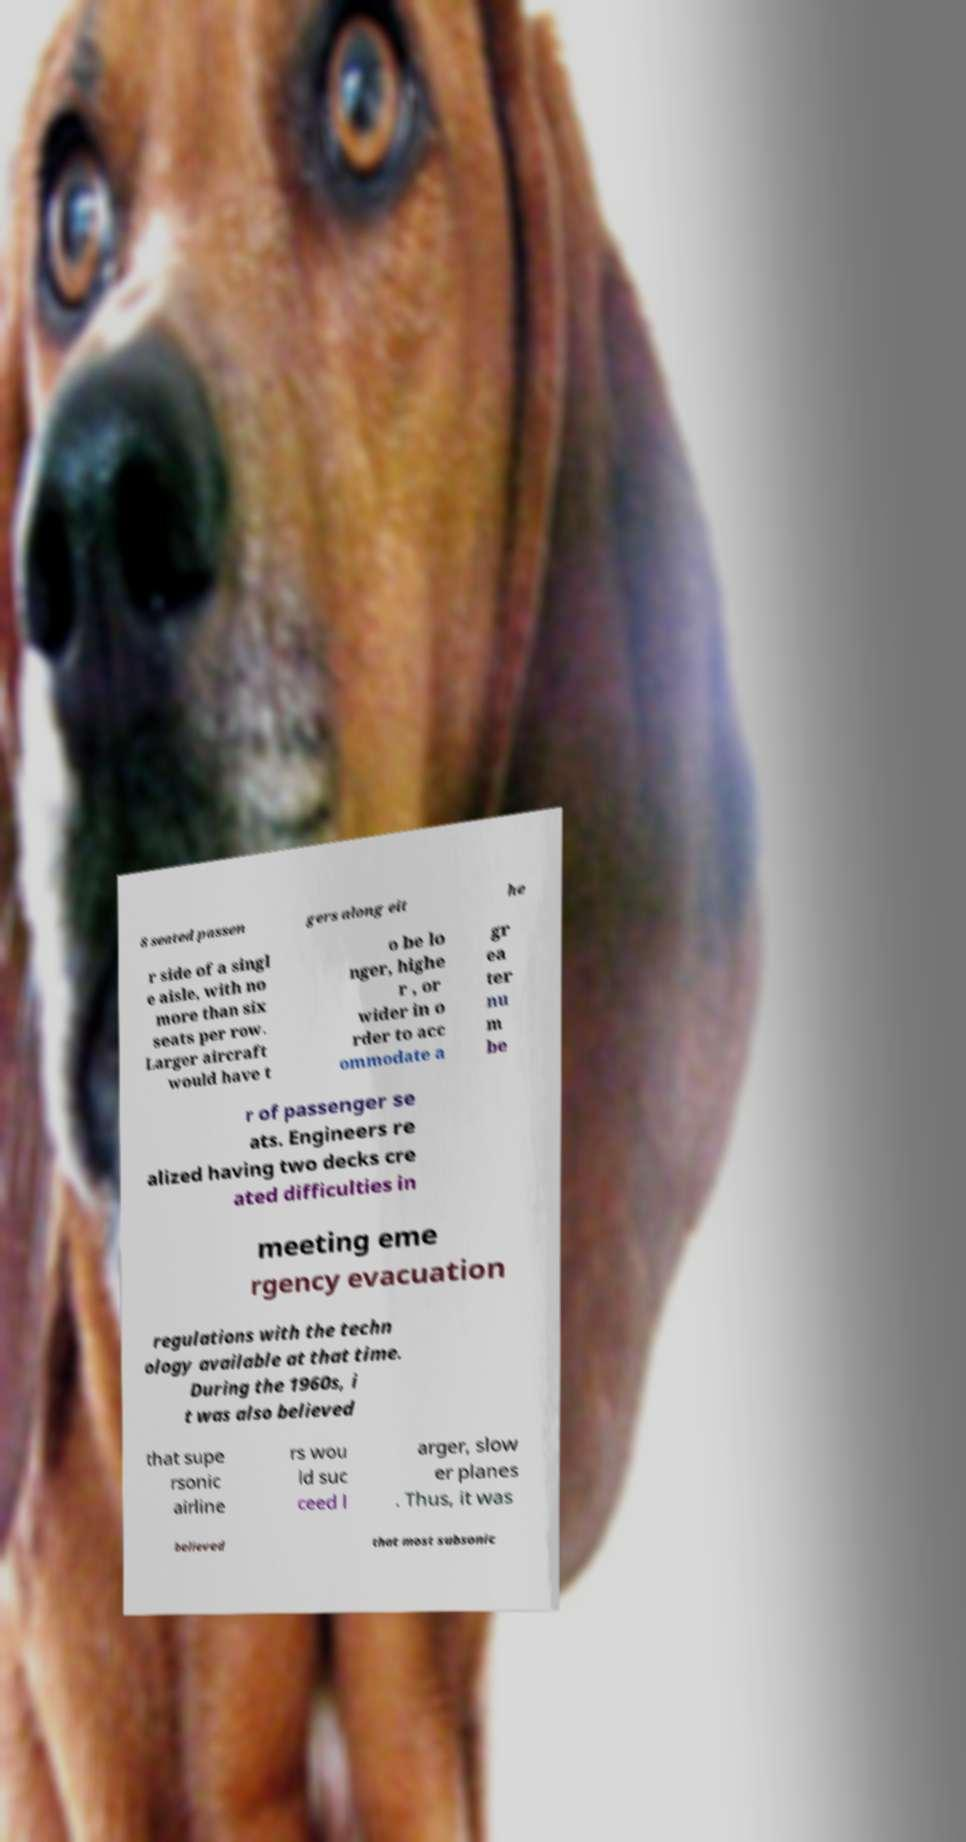Could you assist in decoding the text presented in this image and type it out clearly? 8 seated passen gers along eit he r side of a singl e aisle, with no more than six seats per row. Larger aircraft would have t o be lo nger, highe r , or wider in o rder to acc ommodate a gr ea ter nu m be r of passenger se ats. Engineers re alized having two decks cre ated difficulties in meeting eme rgency evacuation regulations with the techn ology available at that time. During the 1960s, i t was also believed that supe rsonic airline rs wou ld suc ceed l arger, slow er planes . Thus, it was believed that most subsonic 